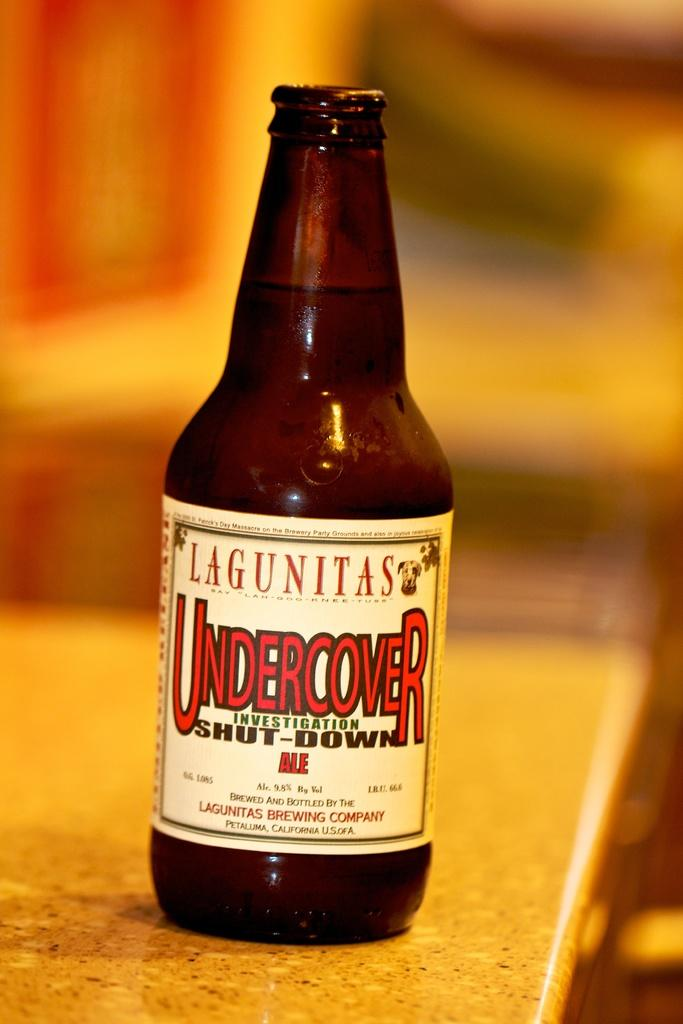Provide a one-sentence caption for the provided image. A bottle of Lagunitas Undercover Investigation Shut Down Ale. 